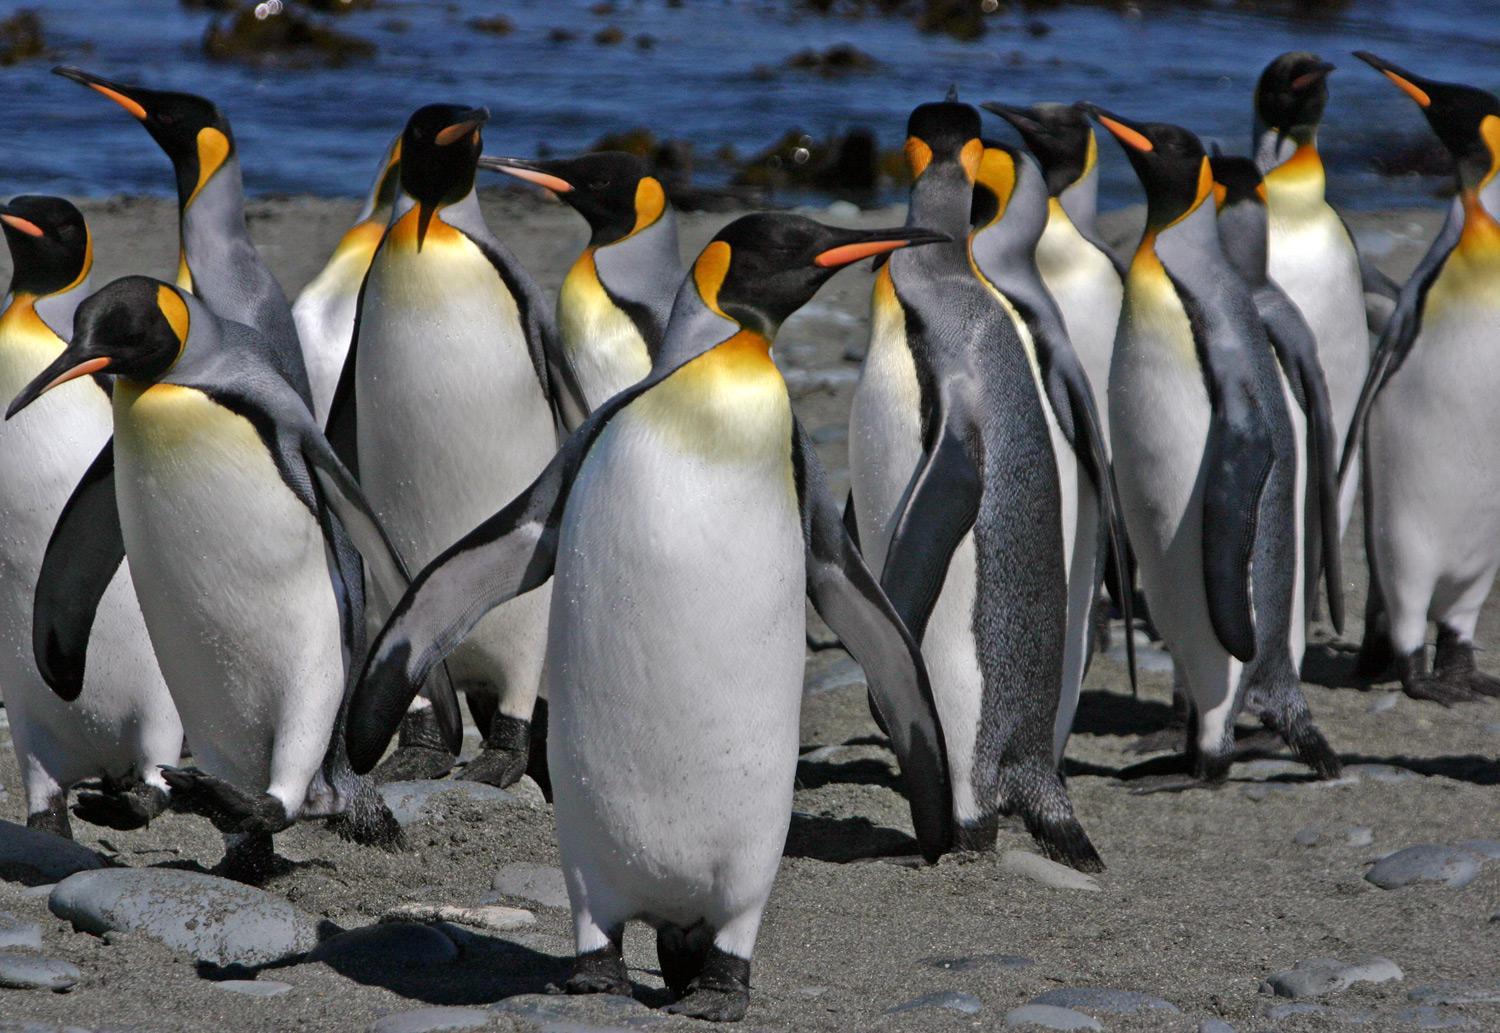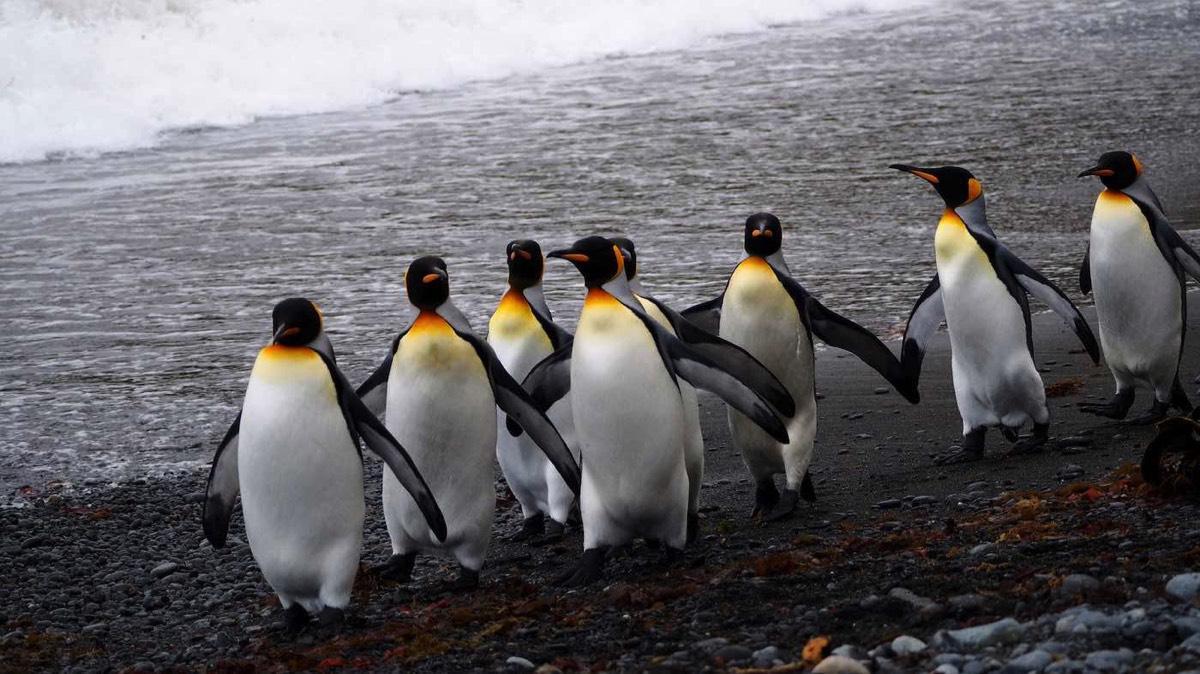The first image is the image on the left, the second image is the image on the right. For the images shown, is this caption "There is exactly one animal in the image on the left." true? Answer yes or no. No. The first image is the image on the left, the second image is the image on the right. Examine the images to the left and right. Is the description "At least one of the images show only one penguin." accurate? Answer yes or no. No. The first image is the image on the left, the second image is the image on the right. For the images displayed, is the sentence "In at least 1 of the images, there is 1 penguin standing toward the left." factually correct? Answer yes or no. No. 